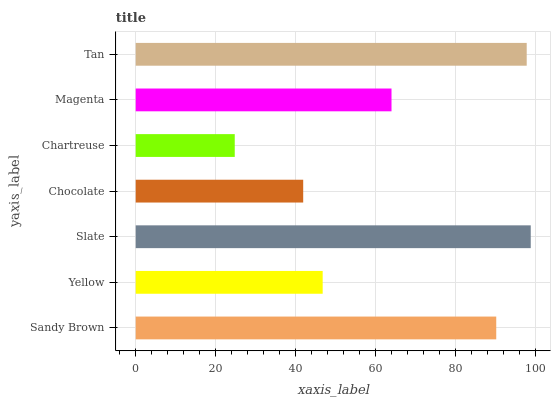Is Chartreuse the minimum?
Answer yes or no. Yes. Is Slate the maximum?
Answer yes or no. Yes. Is Yellow the minimum?
Answer yes or no. No. Is Yellow the maximum?
Answer yes or no. No. Is Sandy Brown greater than Yellow?
Answer yes or no. Yes. Is Yellow less than Sandy Brown?
Answer yes or no. Yes. Is Yellow greater than Sandy Brown?
Answer yes or no. No. Is Sandy Brown less than Yellow?
Answer yes or no. No. Is Magenta the high median?
Answer yes or no. Yes. Is Magenta the low median?
Answer yes or no. Yes. Is Yellow the high median?
Answer yes or no. No. Is Chartreuse the low median?
Answer yes or no. No. 